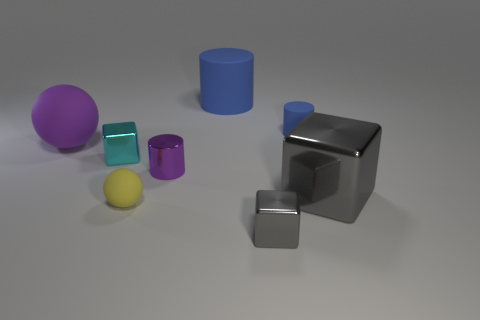The ball in front of the tiny metallic cube that is behind the gray thing that is behind the small yellow rubber sphere is what color?
Your answer should be compact. Yellow. Do the big cylinder and the cylinder that is to the right of the big blue object have the same material?
Your response must be concise. Yes. There is another matte thing that is the same shape as the large purple rubber thing; what is its size?
Provide a succinct answer. Small. Are there the same number of small blue cylinders that are in front of the large cube and small objects that are in front of the large purple ball?
Keep it short and to the point. No. What number of other things are there of the same material as the small blue cylinder
Your answer should be very brief. 3. Are there an equal number of large cylinders in front of the cyan block and tiny purple things?
Offer a terse response. No. There is a purple rubber thing; is its size the same as the cylinder in front of the tiny cyan shiny cube?
Keep it short and to the point. No. What shape is the large thing left of the small yellow ball?
Provide a succinct answer. Sphere. Is there any other thing that has the same shape as the large gray metallic object?
Make the answer very short. Yes. Is the number of purple objects the same as the number of tiny rubber cylinders?
Ensure brevity in your answer.  No. 